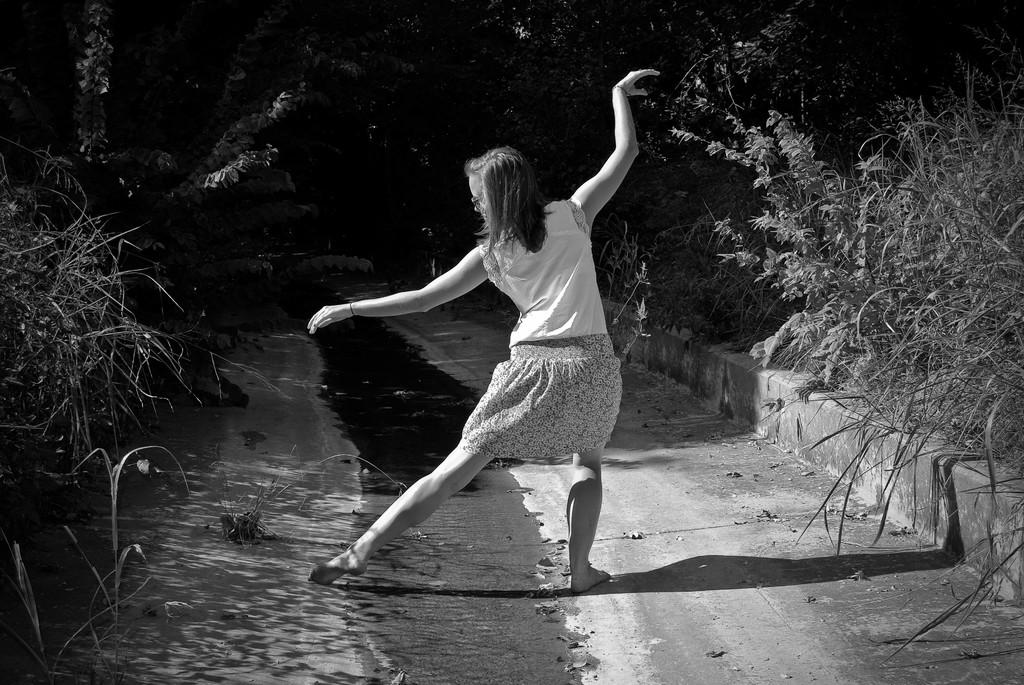What is the woman in the image doing? The woman is dancing in the image. What can be seen in the background of the image? The path is visible in the image, with plants and trees on either side. What is the color scheme of the image? The image is black and white. Where is the man hiding in the cave in the image? There is no man or cave present in the image; it features a woman dancing on a path surrounded by plants and trees. 